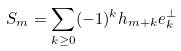<formula> <loc_0><loc_0><loc_500><loc_500>S _ { m } = \sum _ { k \geq 0 } ( - 1 ) ^ { k } h _ { m + k } e _ { k } ^ { \perp }</formula> 